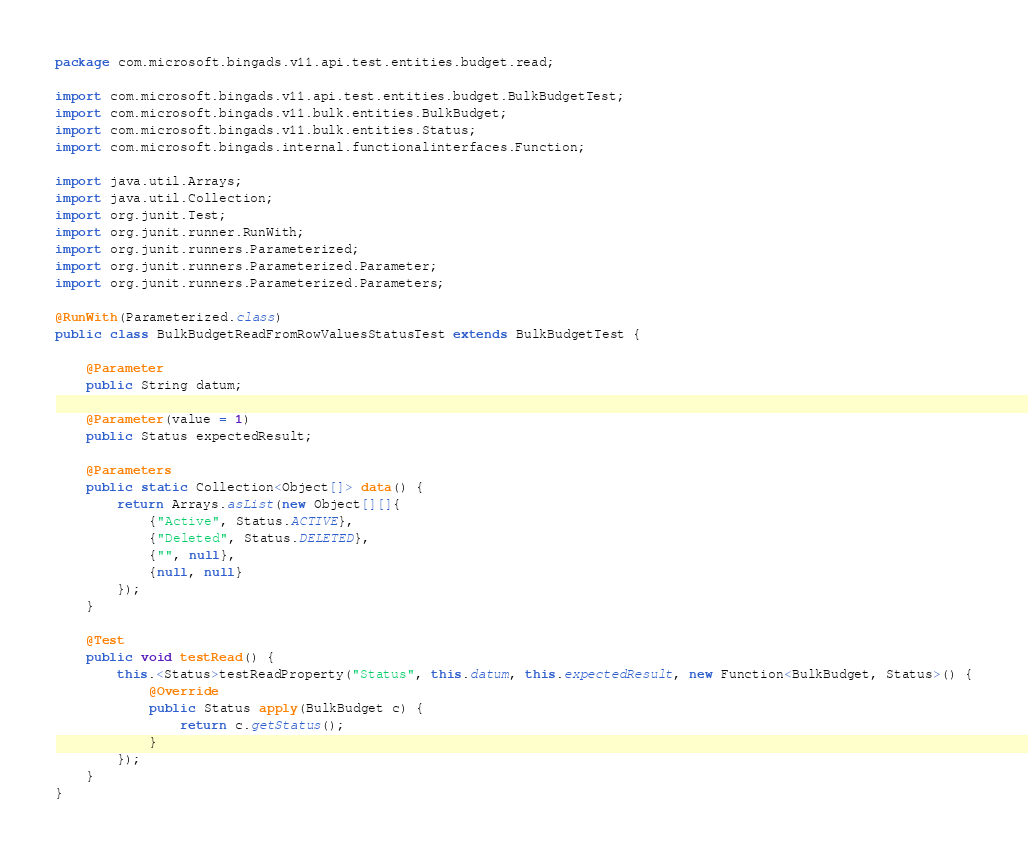Convert code to text. <code><loc_0><loc_0><loc_500><loc_500><_Java_>package com.microsoft.bingads.v11.api.test.entities.budget.read;

import com.microsoft.bingads.v11.api.test.entities.budget.BulkBudgetTest;
import com.microsoft.bingads.v11.bulk.entities.BulkBudget;
import com.microsoft.bingads.v11.bulk.entities.Status;
import com.microsoft.bingads.internal.functionalinterfaces.Function;

import java.util.Arrays;
import java.util.Collection;
import org.junit.Test;
import org.junit.runner.RunWith;
import org.junit.runners.Parameterized;
import org.junit.runners.Parameterized.Parameter;
import org.junit.runners.Parameterized.Parameters;

@RunWith(Parameterized.class)
public class BulkBudgetReadFromRowValuesStatusTest extends BulkBudgetTest {

    @Parameter
    public String datum;

    @Parameter(value = 1)
    public Status expectedResult;

    @Parameters
    public static Collection<Object[]> data() {
        return Arrays.asList(new Object[][]{
            {"Active", Status.ACTIVE},
            {"Deleted", Status.DELETED},
            {"", null},
            {null, null}
        });
    }

    @Test
    public void testRead() {
        this.<Status>testReadProperty("Status", this.datum, this.expectedResult, new Function<BulkBudget, Status>() {
            @Override
            public Status apply(BulkBudget c) {
                return c.getStatus();
            }
        });
    }
}
</code> 